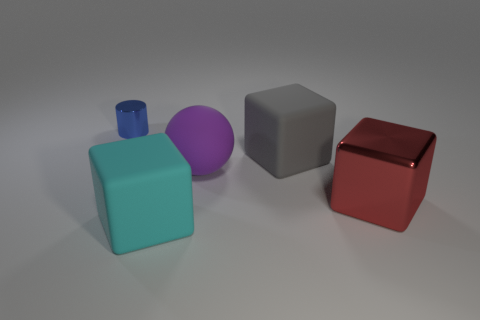Subtract all large cyan matte blocks. How many blocks are left? 2 Subtract all gray cubes. How many cubes are left? 2 Add 2 yellow objects. How many objects exist? 7 Add 5 large red blocks. How many large red blocks exist? 6 Subtract 0 purple cylinders. How many objects are left? 5 Subtract all cubes. How many objects are left? 2 Subtract 1 cylinders. How many cylinders are left? 0 Subtract all red blocks. Subtract all brown spheres. How many blocks are left? 2 Subtract all red cylinders. How many brown cubes are left? 0 Subtract all spheres. Subtract all gray cubes. How many objects are left? 3 